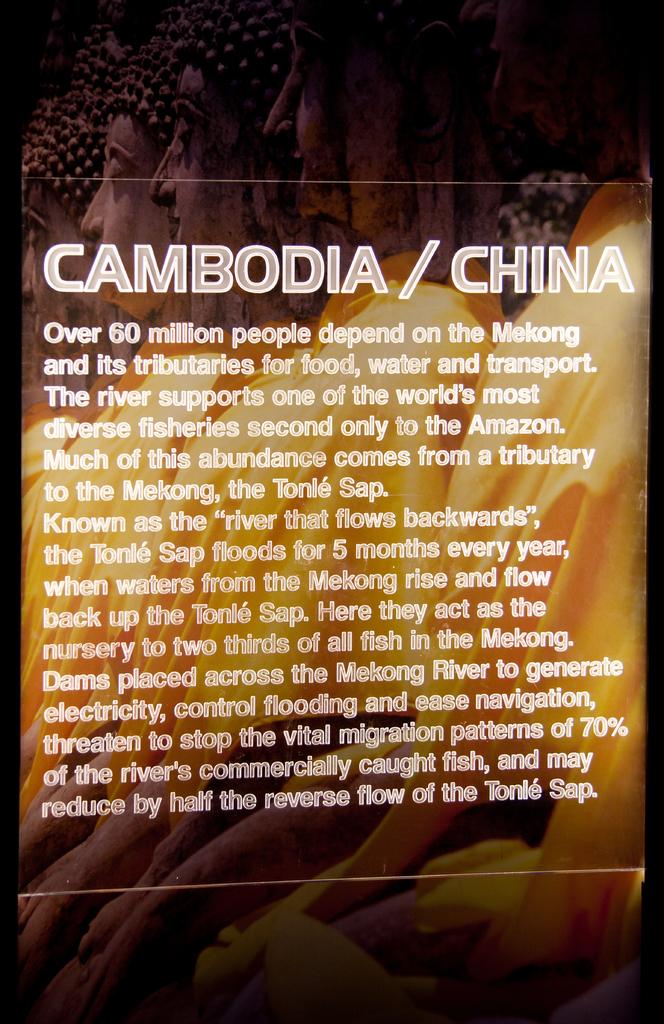What country is shown next to cambodia?
Ensure brevity in your answer.  China. Is the mekong river important to china?
Make the answer very short. Yes. 